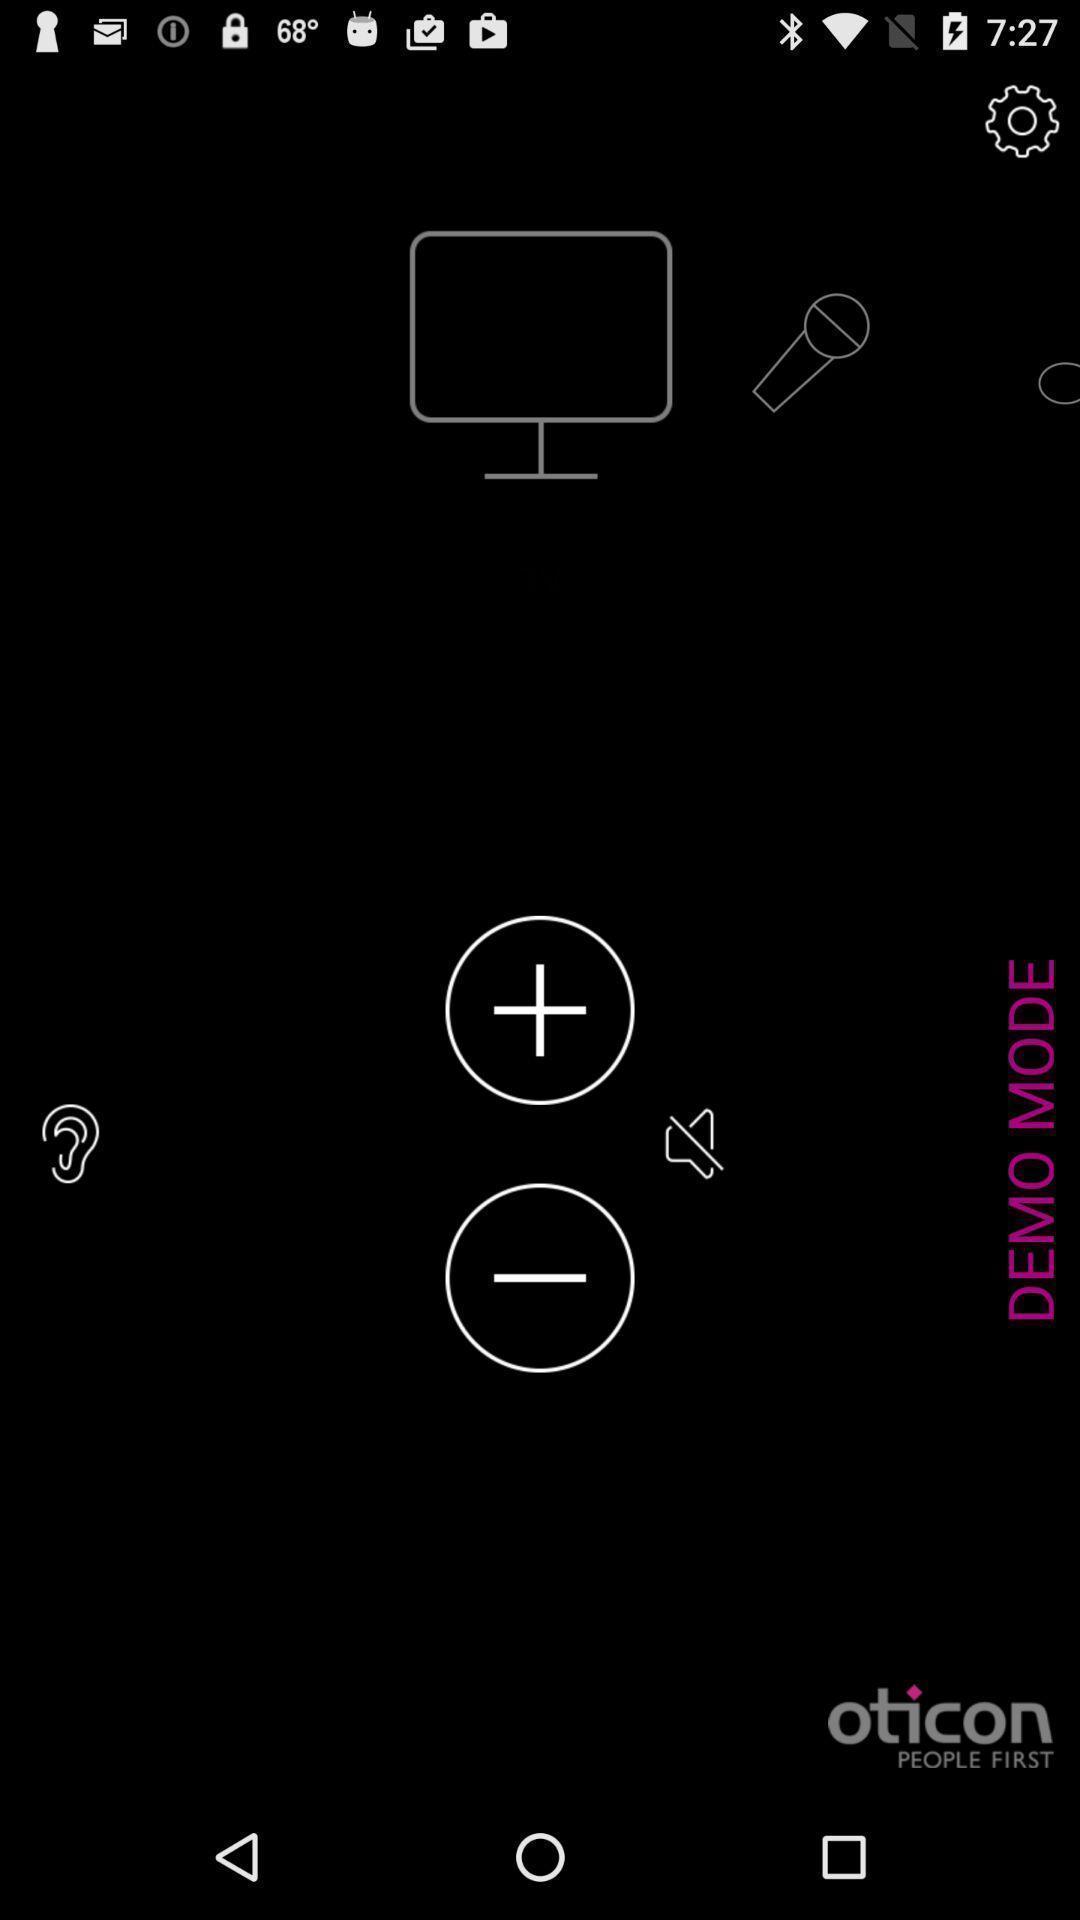Describe the key features of this screenshot. Page showing the options in network connection app. 